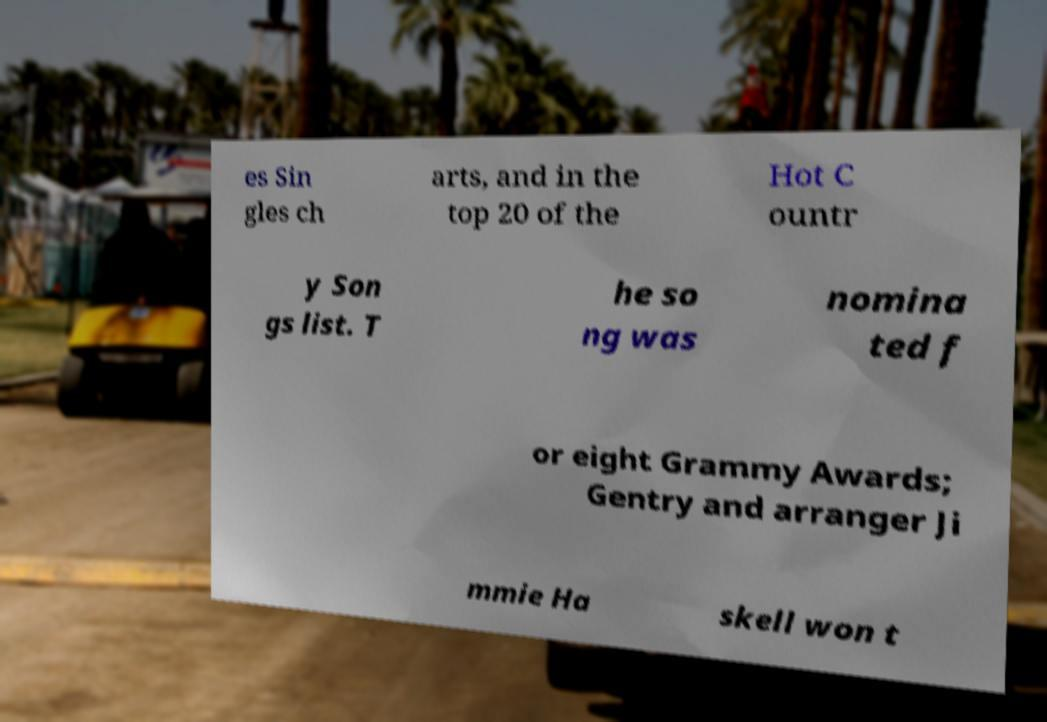Could you extract and type out the text from this image? es Sin gles ch arts, and in the top 20 of the Hot C ountr y Son gs list. T he so ng was nomina ted f or eight Grammy Awards; Gentry and arranger Ji mmie Ha skell won t 